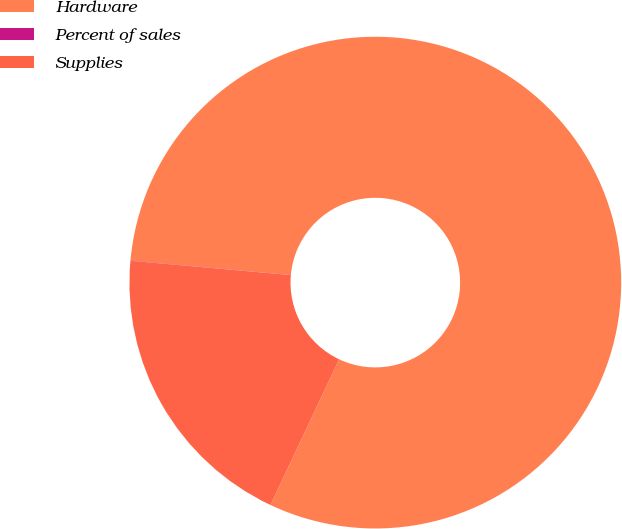Convert chart. <chart><loc_0><loc_0><loc_500><loc_500><pie_chart><fcel>Hardware<fcel>Percent of sales<fcel>Supplies<nl><fcel>80.58%<fcel>0.02%<fcel>19.41%<nl></chart> 